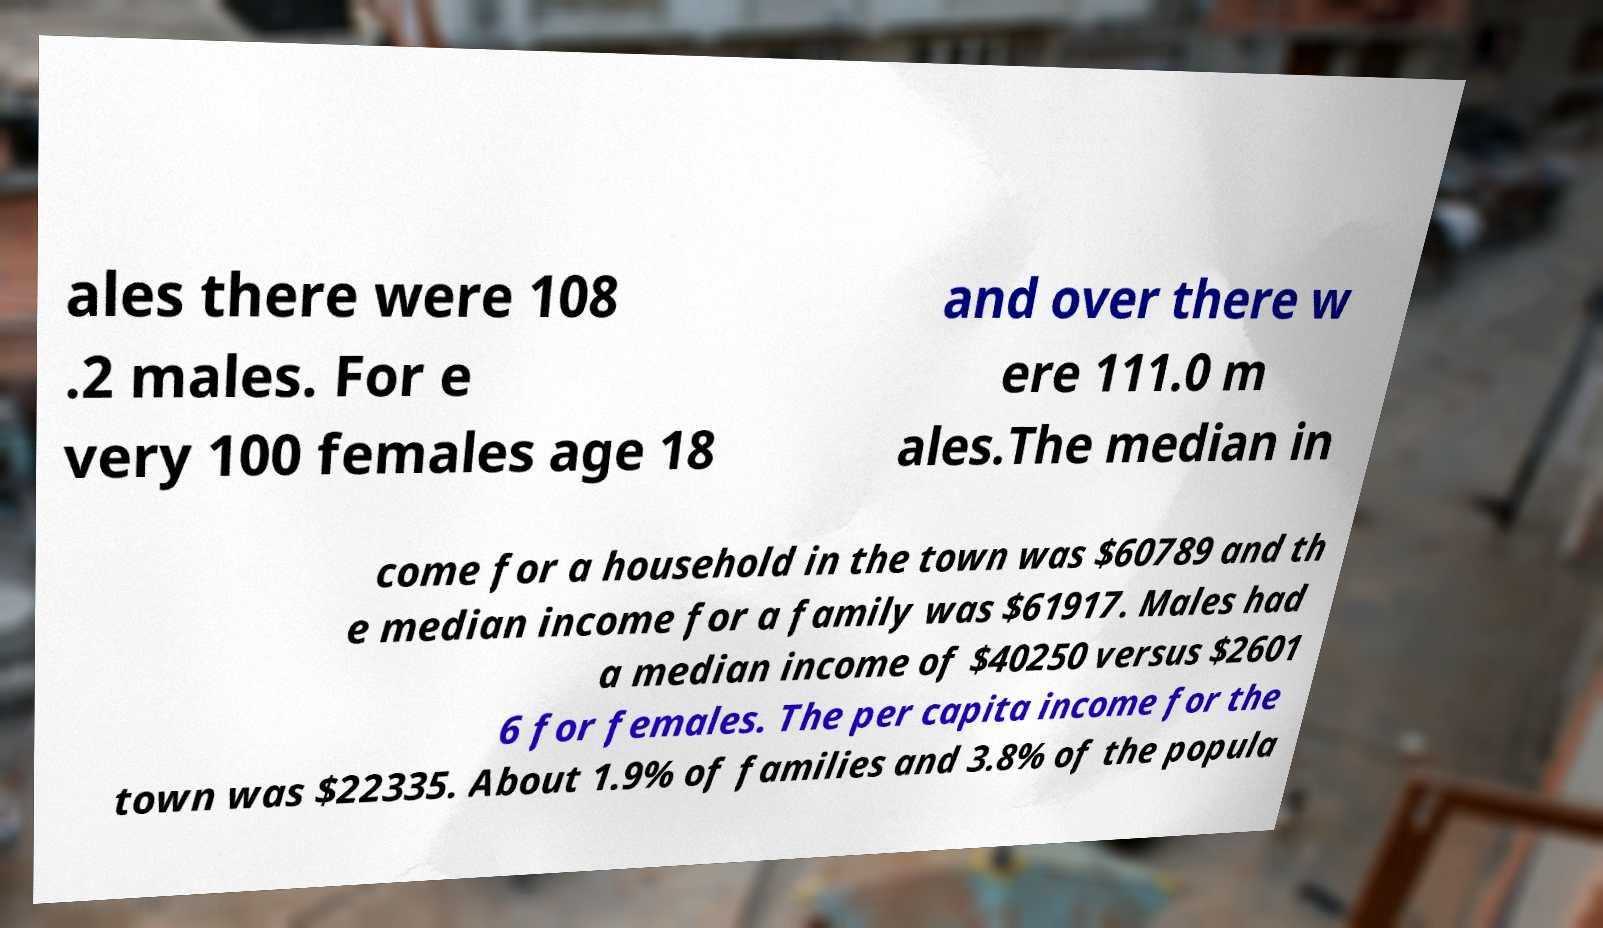I need the written content from this picture converted into text. Can you do that? ales there were 108 .2 males. For e very 100 females age 18 and over there w ere 111.0 m ales.The median in come for a household in the town was $60789 and th e median income for a family was $61917. Males had a median income of $40250 versus $2601 6 for females. The per capita income for the town was $22335. About 1.9% of families and 3.8% of the popula 